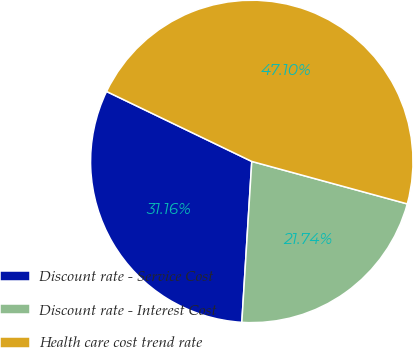Convert chart to OTSL. <chart><loc_0><loc_0><loc_500><loc_500><pie_chart><fcel>Discount rate - Service Cost<fcel>Discount rate - Interest Cost<fcel>Health care cost trend rate<nl><fcel>31.16%<fcel>21.74%<fcel>47.1%<nl></chart> 